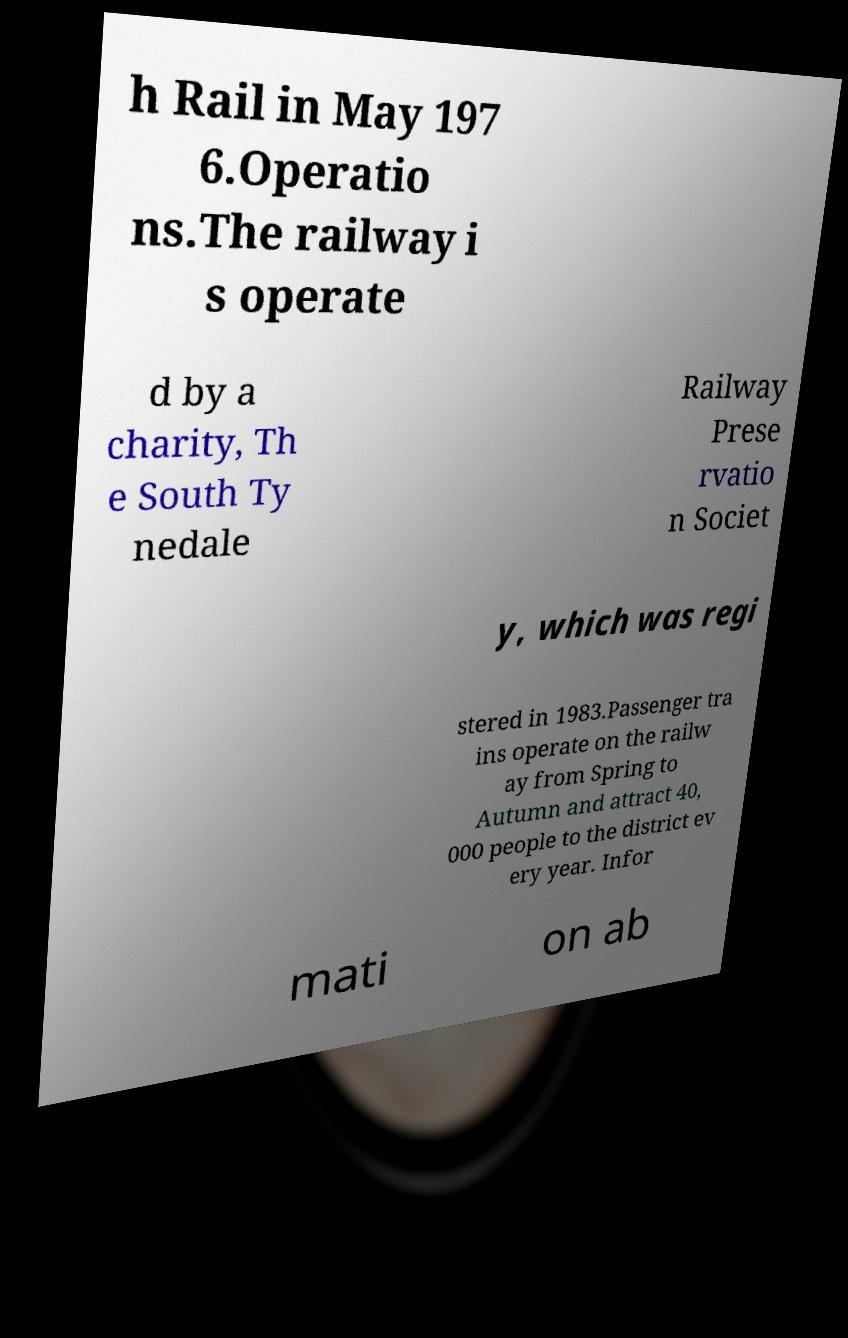Can you read and provide the text displayed in the image?This photo seems to have some interesting text. Can you extract and type it out for me? h Rail in May 197 6.Operatio ns.The railway i s operate d by a charity, Th e South Ty nedale Railway Prese rvatio n Societ y, which was regi stered in 1983.Passenger tra ins operate on the railw ay from Spring to Autumn and attract 40, 000 people to the district ev ery year. Infor mati on ab 